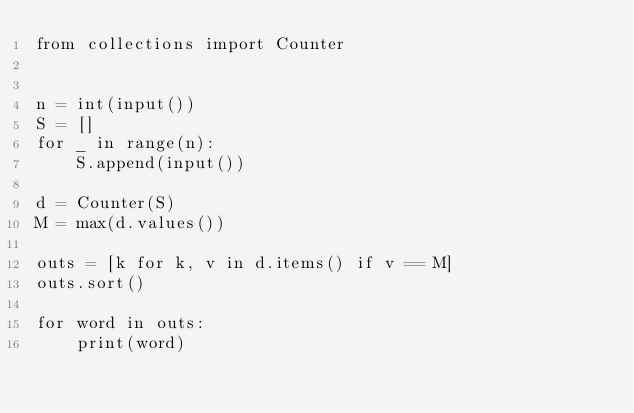Convert code to text. <code><loc_0><loc_0><loc_500><loc_500><_Python_>from collections import Counter


n = int(input())
S = []
for _ in range(n):
    S.append(input())

d = Counter(S)
M = max(d.values())

outs = [k for k, v in d.items() if v == M]
outs.sort()

for word in outs:
    print(word)</code> 